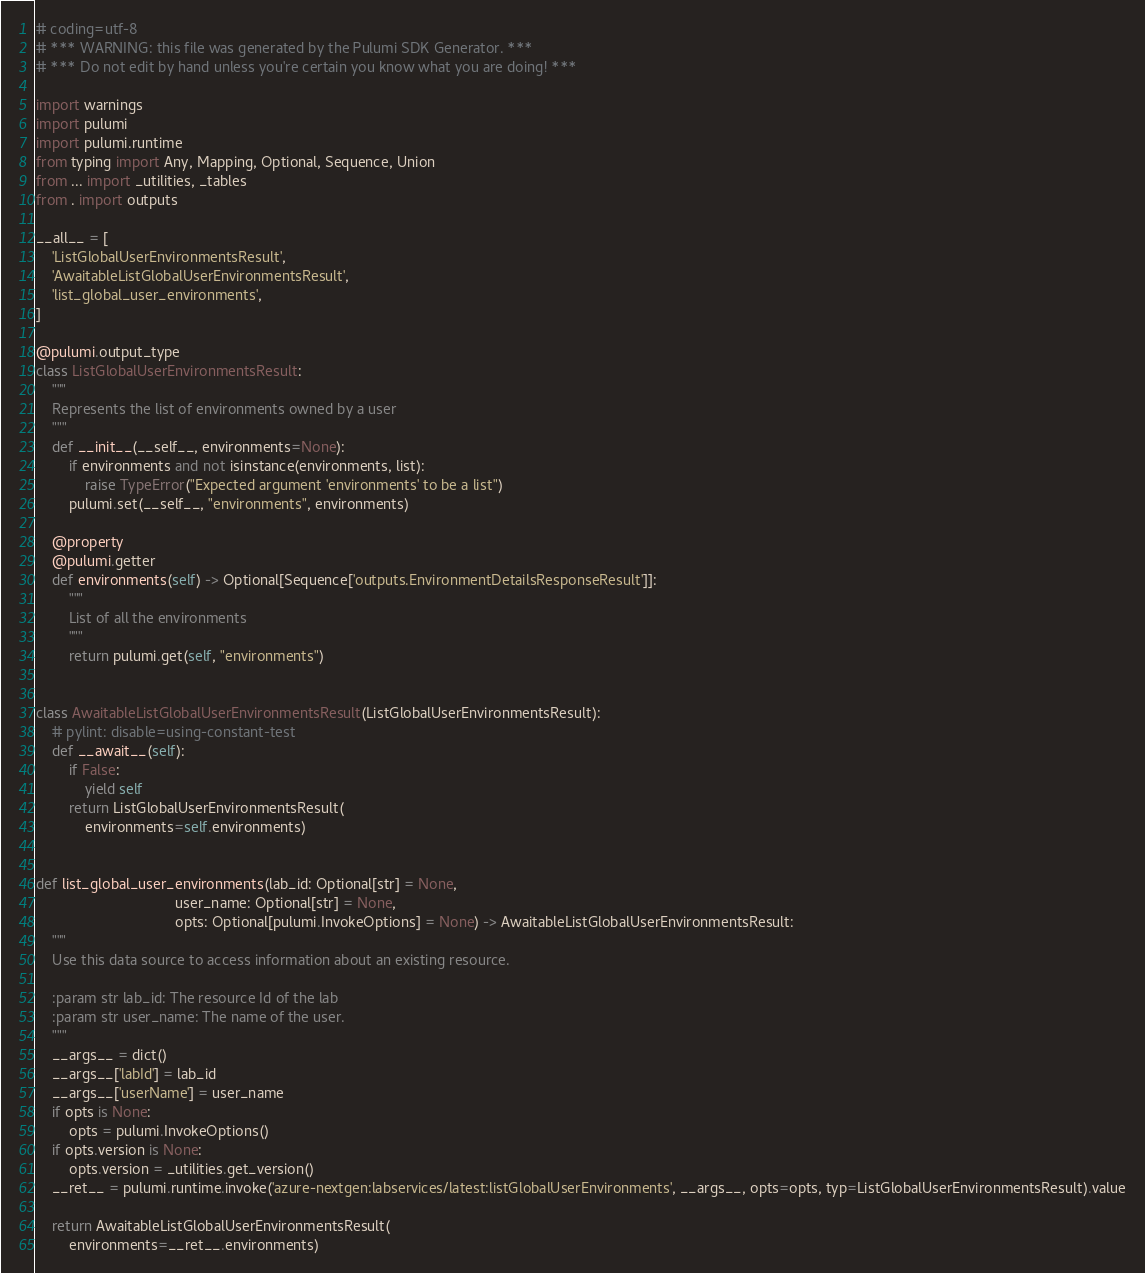<code> <loc_0><loc_0><loc_500><loc_500><_Python_># coding=utf-8
# *** WARNING: this file was generated by the Pulumi SDK Generator. ***
# *** Do not edit by hand unless you're certain you know what you are doing! ***

import warnings
import pulumi
import pulumi.runtime
from typing import Any, Mapping, Optional, Sequence, Union
from ... import _utilities, _tables
from . import outputs

__all__ = [
    'ListGlobalUserEnvironmentsResult',
    'AwaitableListGlobalUserEnvironmentsResult',
    'list_global_user_environments',
]

@pulumi.output_type
class ListGlobalUserEnvironmentsResult:
    """
    Represents the list of environments owned by a user
    """
    def __init__(__self__, environments=None):
        if environments and not isinstance(environments, list):
            raise TypeError("Expected argument 'environments' to be a list")
        pulumi.set(__self__, "environments", environments)

    @property
    @pulumi.getter
    def environments(self) -> Optional[Sequence['outputs.EnvironmentDetailsResponseResult']]:
        """
        List of all the environments
        """
        return pulumi.get(self, "environments")


class AwaitableListGlobalUserEnvironmentsResult(ListGlobalUserEnvironmentsResult):
    # pylint: disable=using-constant-test
    def __await__(self):
        if False:
            yield self
        return ListGlobalUserEnvironmentsResult(
            environments=self.environments)


def list_global_user_environments(lab_id: Optional[str] = None,
                                  user_name: Optional[str] = None,
                                  opts: Optional[pulumi.InvokeOptions] = None) -> AwaitableListGlobalUserEnvironmentsResult:
    """
    Use this data source to access information about an existing resource.

    :param str lab_id: The resource Id of the lab
    :param str user_name: The name of the user.
    """
    __args__ = dict()
    __args__['labId'] = lab_id
    __args__['userName'] = user_name
    if opts is None:
        opts = pulumi.InvokeOptions()
    if opts.version is None:
        opts.version = _utilities.get_version()
    __ret__ = pulumi.runtime.invoke('azure-nextgen:labservices/latest:listGlobalUserEnvironments', __args__, opts=opts, typ=ListGlobalUserEnvironmentsResult).value

    return AwaitableListGlobalUserEnvironmentsResult(
        environments=__ret__.environments)
</code> 